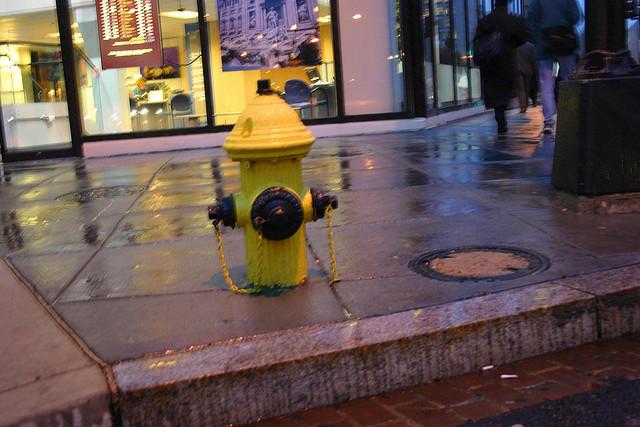Are there bricks in this photo?
Give a very brief answer. Yes. What is the yellow thing?
Write a very short answer. Hydrant. Is the ground damp?
Write a very short answer. Yes. 